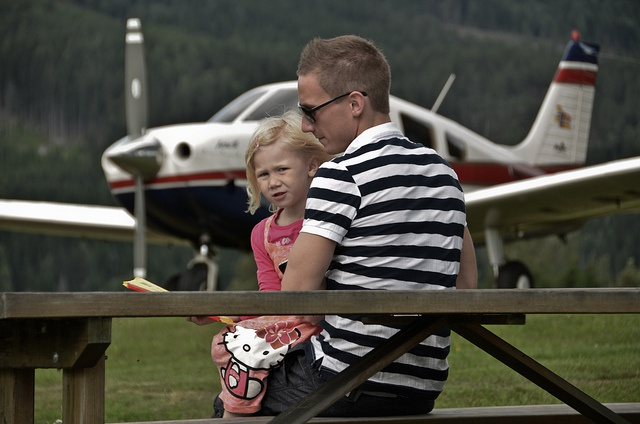Describe the objects in this image and their specific colors. I can see people in black, gray, and darkgray tones, airplane in black, darkgray, gray, and white tones, bench in black and gray tones, and people in black, brown, darkgray, and gray tones in this image. 